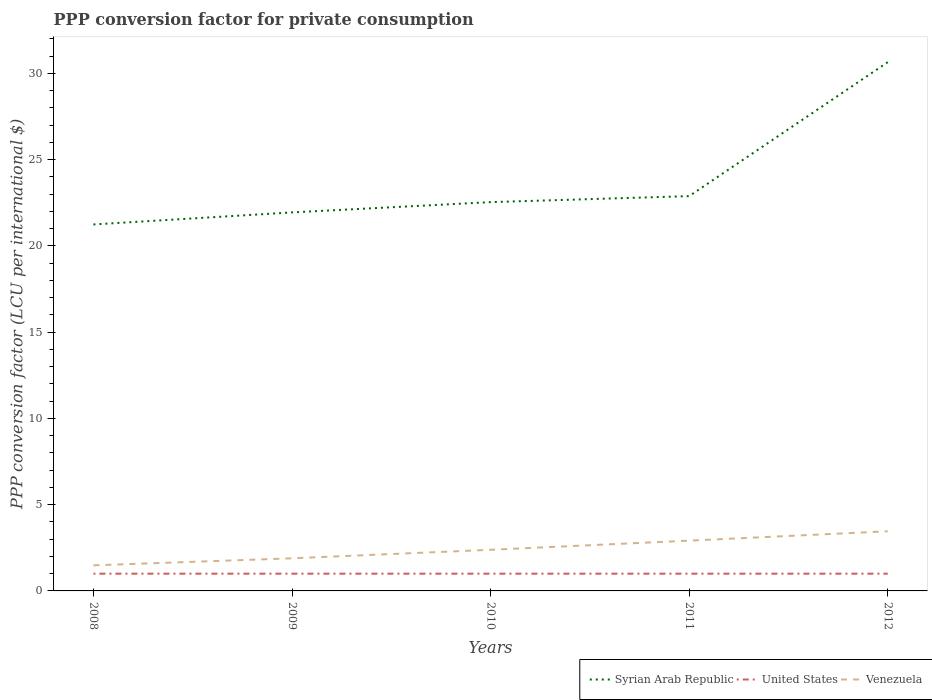Across all years, what is the maximum PPP conversion factor for private consumption in Venezuela?
Your response must be concise. 1.48. What is the total PPP conversion factor for private consumption in Syrian Arab Republic in the graph?
Keep it short and to the point. -7.77. What is the difference between the highest and the second highest PPP conversion factor for private consumption in Syrian Arab Republic?
Make the answer very short. 9.41. Is the PPP conversion factor for private consumption in United States strictly greater than the PPP conversion factor for private consumption in Syrian Arab Republic over the years?
Offer a very short reply. Yes. How many years are there in the graph?
Provide a short and direct response. 5. What is the difference between two consecutive major ticks on the Y-axis?
Provide a short and direct response. 5. Does the graph contain any zero values?
Your answer should be very brief. No. Does the graph contain grids?
Offer a terse response. No. Where does the legend appear in the graph?
Give a very brief answer. Bottom right. How are the legend labels stacked?
Give a very brief answer. Horizontal. What is the title of the graph?
Offer a terse response. PPP conversion factor for private consumption. What is the label or title of the X-axis?
Give a very brief answer. Years. What is the label or title of the Y-axis?
Keep it short and to the point. PPP conversion factor (LCU per international $). What is the PPP conversion factor (LCU per international $) of Syrian Arab Republic in 2008?
Offer a terse response. 21.24. What is the PPP conversion factor (LCU per international $) in Venezuela in 2008?
Ensure brevity in your answer.  1.48. What is the PPP conversion factor (LCU per international $) in Syrian Arab Republic in 2009?
Ensure brevity in your answer.  21.94. What is the PPP conversion factor (LCU per international $) in United States in 2009?
Give a very brief answer. 1. What is the PPP conversion factor (LCU per international $) of Venezuela in 2009?
Make the answer very short. 1.89. What is the PPP conversion factor (LCU per international $) in Syrian Arab Republic in 2010?
Your answer should be very brief. 22.54. What is the PPP conversion factor (LCU per international $) of United States in 2010?
Provide a succinct answer. 1. What is the PPP conversion factor (LCU per international $) of Venezuela in 2010?
Give a very brief answer. 2.38. What is the PPP conversion factor (LCU per international $) of Syrian Arab Republic in 2011?
Provide a succinct answer. 22.89. What is the PPP conversion factor (LCU per international $) in United States in 2011?
Your answer should be compact. 1. What is the PPP conversion factor (LCU per international $) of Venezuela in 2011?
Provide a succinct answer. 2.92. What is the PPP conversion factor (LCU per international $) of Syrian Arab Republic in 2012?
Offer a very short reply. 30.65. What is the PPP conversion factor (LCU per international $) of Venezuela in 2012?
Your answer should be very brief. 3.46. Across all years, what is the maximum PPP conversion factor (LCU per international $) of Syrian Arab Republic?
Your response must be concise. 30.65. Across all years, what is the maximum PPP conversion factor (LCU per international $) in Venezuela?
Provide a short and direct response. 3.46. Across all years, what is the minimum PPP conversion factor (LCU per international $) in Syrian Arab Republic?
Provide a succinct answer. 21.24. Across all years, what is the minimum PPP conversion factor (LCU per international $) of United States?
Offer a terse response. 1. Across all years, what is the minimum PPP conversion factor (LCU per international $) of Venezuela?
Your answer should be compact. 1.48. What is the total PPP conversion factor (LCU per international $) of Syrian Arab Republic in the graph?
Offer a very short reply. 119.26. What is the total PPP conversion factor (LCU per international $) of Venezuela in the graph?
Offer a very short reply. 12.13. What is the difference between the PPP conversion factor (LCU per international $) of Syrian Arab Republic in 2008 and that in 2009?
Your answer should be compact. -0.7. What is the difference between the PPP conversion factor (LCU per international $) in United States in 2008 and that in 2009?
Your answer should be very brief. 0. What is the difference between the PPP conversion factor (LCU per international $) in Venezuela in 2008 and that in 2009?
Provide a succinct answer. -0.41. What is the difference between the PPP conversion factor (LCU per international $) of Syrian Arab Republic in 2008 and that in 2010?
Offer a very short reply. -1.29. What is the difference between the PPP conversion factor (LCU per international $) of Venezuela in 2008 and that in 2010?
Ensure brevity in your answer.  -0.9. What is the difference between the PPP conversion factor (LCU per international $) of Syrian Arab Republic in 2008 and that in 2011?
Your answer should be very brief. -1.64. What is the difference between the PPP conversion factor (LCU per international $) in United States in 2008 and that in 2011?
Your response must be concise. 0. What is the difference between the PPP conversion factor (LCU per international $) in Venezuela in 2008 and that in 2011?
Your answer should be very brief. -1.43. What is the difference between the PPP conversion factor (LCU per international $) in Syrian Arab Republic in 2008 and that in 2012?
Your answer should be very brief. -9.41. What is the difference between the PPP conversion factor (LCU per international $) in Venezuela in 2008 and that in 2012?
Offer a very short reply. -1.97. What is the difference between the PPP conversion factor (LCU per international $) of Syrian Arab Republic in 2009 and that in 2010?
Provide a succinct answer. -0.6. What is the difference between the PPP conversion factor (LCU per international $) of Venezuela in 2009 and that in 2010?
Your answer should be compact. -0.49. What is the difference between the PPP conversion factor (LCU per international $) in Syrian Arab Republic in 2009 and that in 2011?
Your answer should be very brief. -0.94. What is the difference between the PPP conversion factor (LCU per international $) in Venezuela in 2009 and that in 2011?
Your answer should be compact. -1.02. What is the difference between the PPP conversion factor (LCU per international $) in Syrian Arab Republic in 2009 and that in 2012?
Your answer should be very brief. -8.71. What is the difference between the PPP conversion factor (LCU per international $) of United States in 2009 and that in 2012?
Provide a short and direct response. 0. What is the difference between the PPP conversion factor (LCU per international $) of Venezuela in 2009 and that in 2012?
Make the answer very short. -1.57. What is the difference between the PPP conversion factor (LCU per international $) in Syrian Arab Republic in 2010 and that in 2011?
Offer a terse response. -0.35. What is the difference between the PPP conversion factor (LCU per international $) in Venezuela in 2010 and that in 2011?
Give a very brief answer. -0.53. What is the difference between the PPP conversion factor (LCU per international $) of Syrian Arab Republic in 2010 and that in 2012?
Provide a short and direct response. -8.11. What is the difference between the PPP conversion factor (LCU per international $) of Venezuela in 2010 and that in 2012?
Provide a succinct answer. -1.07. What is the difference between the PPP conversion factor (LCU per international $) of Syrian Arab Republic in 2011 and that in 2012?
Your answer should be compact. -7.77. What is the difference between the PPP conversion factor (LCU per international $) of Venezuela in 2011 and that in 2012?
Give a very brief answer. -0.54. What is the difference between the PPP conversion factor (LCU per international $) in Syrian Arab Republic in 2008 and the PPP conversion factor (LCU per international $) in United States in 2009?
Offer a terse response. 20.24. What is the difference between the PPP conversion factor (LCU per international $) of Syrian Arab Republic in 2008 and the PPP conversion factor (LCU per international $) of Venezuela in 2009?
Your answer should be very brief. 19.35. What is the difference between the PPP conversion factor (LCU per international $) of United States in 2008 and the PPP conversion factor (LCU per international $) of Venezuela in 2009?
Provide a succinct answer. -0.89. What is the difference between the PPP conversion factor (LCU per international $) in Syrian Arab Republic in 2008 and the PPP conversion factor (LCU per international $) in United States in 2010?
Your response must be concise. 20.24. What is the difference between the PPP conversion factor (LCU per international $) in Syrian Arab Republic in 2008 and the PPP conversion factor (LCU per international $) in Venezuela in 2010?
Keep it short and to the point. 18.86. What is the difference between the PPP conversion factor (LCU per international $) of United States in 2008 and the PPP conversion factor (LCU per international $) of Venezuela in 2010?
Give a very brief answer. -1.38. What is the difference between the PPP conversion factor (LCU per international $) of Syrian Arab Republic in 2008 and the PPP conversion factor (LCU per international $) of United States in 2011?
Give a very brief answer. 20.24. What is the difference between the PPP conversion factor (LCU per international $) in Syrian Arab Republic in 2008 and the PPP conversion factor (LCU per international $) in Venezuela in 2011?
Offer a terse response. 18.33. What is the difference between the PPP conversion factor (LCU per international $) of United States in 2008 and the PPP conversion factor (LCU per international $) of Venezuela in 2011?
Your response must be concise. -1.92. What is the difference between the PPP conversion factor (LCU per international $) of Syrian Arab Republic in 2008 and the PPP conversion factor (LCU per international $) of United States in 2012?
Ensure brevity in your answer.  20.24. What is the difference between the PPP conversion factor (LCU per international $) in Syrian Arab Republic in 2008 and the PPP conversion factor (LCU per international $) in Venezuela in 2012?
Your answer should be compact. 17.79. What is the difference between the PPP conversion factor (LCU per international $) in United States in 2008 and the PPP conversion factor (LCU per international $) in Venezuela in 2012?
Keep it short and to the point. -2.46. What is the difference between the PPP conversion factor (LCU per international $) in Syrian Arab Republic in 2009 and the PPP conversion factor (LCU per international $) in United States in 2010?
Your answer should be very brief. 20.94. What is the difference between the PPP conversion factor (LCU per international $) in Syrian Arab Republic in 2009 and the PPP conversion factor (LCU per international $) in Venezuela in 2010?
Ensure brevity in your answer.  19.56. What is the difference between the PPP conversion factor (LCU per international $) in United States in 2009 and the PPP conversion factor (LCU per international $) in Venezuela in 2010?
Provide a short and direct response. -1.38. What is the difference between the PPP conversion factor (LCU per international $) of Syrian Arab Republic in 2009 and the PPP conversion factor (LCU per international $) of United States in 2011?
Provide a succinct answer. 20.94. What is the difference between the PPP conversion factor (LCU per international $) of Syrian Arab Republic in 2009 and the PPP conversion factor (LCU per international $) of Venezuela in 2011?
Offer a very short reply. 19.03. What is the difference between the PPP conversion factor (LCU per international $) of United States in 2009 and the PPP conversion factor (LCU per international $) of Venezuela in 2011?
Provide a short and direct response. -1.92. What is the difference between the PPP conversion factor (LCU per international $) in Syrian Arab Republic in 2009 and the PPP conversion factor (LCU per international $) in United States in 2012?
Offer a terse response. 20.94. What is the difference between the PPP conversion factor (LCU per international $) of Syrian Arab Republic in 2009 and the PPP conversion factor (LCU per international $) of Venezuela in 2012?
Offer a terse response. 18.48. What is the difference between the PPP conversion factor (LCU per international $) of United States in 2009 and the PPP conversion factor (LCU per international $) of Venezuela in 2012?
Offer a terse response. -2.46. What is the difference between the PPP conversion factor (LCU per international $) of Syrian Arab Republic in 2010 and the PPP conversion factor (LCU per international $) of United States in 2011?
Your response must be concise. 21.54. What is the difference between the PPP conversion factor (LCU per international $) of Syrian Arab Republic in 2010 and the PPP conversion factor (LCU per international $) of Venezuela in 2011?
Provide a short and direct response. 19.62. What is the difference between the PPP conversion factor (LCU per international $) of United States in 2010 and the PPP conversion factor (LCU per international $) of Venezuela in 2011?
Your answer should be compact. -1.92. What is the difference between the PPP conversion factor (LCU per international $) of Syrian Arab Republic in 2010 and the PPP conversion factor (LCU per international $) of United States in 2012?
Provide a succinct answer. 21.54. What is the difference between the PPP conversion factor (LCU per international $) in Syrian Arab Republic in 2010 and the PPP conversion factor (LCU per international $) in Venezuela in 2012?
Provide a succinct answer. 19.08. What is the difference between the PPP conversion factor (LCU per international $) of United States in 2010 and the PPP conversion factor (LCU per international $) of Venezuela in 2012?
Give a very brief answer. -2.46. What is the difference between the PPP conversion factor (LCU per international $) in Syrian Arab Republic in 2011 and the PPP conversion factor (LCU per international $) in United States in 2012?
Give a very brief answer. 21.89. What is the difference between the PPP conversion factor (LCU per international $) in Syrian Arab Republic in 2011 and the PPP conversion factor (LCU per international $) in Venezuela in 2012?
Provide a succinct answer. 19.43. What is the difference between the PPP conversion factor (LCU per international $) in United States in 2011 and the PPP conversion factor (LCU per international $) in Venezuela in 2012?
Offer a terse response. -2.46. What is the average PPP conversion factor (LCU per international $) in Syrian Arab Republic per year?
Ensure brevity in your answer.  23.85. What is the average PPP conversion factor (LCU per international $) in Venezuela per year?
Provide a short and direct response. 2.43. In the year 2008, what is the difference between the PPP conversion factor (LCU per international $) in Syrian Arab Republic and PPP conversion factor (LCU per international $) in United States?
Offer a terse response. 20.24. In the year 2008, what is the difference between the PPP conversion factor (LCU per international $) of Syrian Arab Republic and PPP conversion factor (LCU per international $) of Venezuela?
Your answer should be very brief. 19.76. In the year 2008, what is the difference between the PPP conversion factor (LCU per international $) in United States and PPP conversion factor (LCU per international $) in Venezuela?
Provide a short and direct response. -0.48. In the year 2009, what is the difference between the PPP conversion factor (LCU per international $) in Syrian Arab Republic and PPP conversion factor (LCU per international $) in United States?
Give a very brief answer. 20.94. In the year 2009, what is the difference between the PPP conversion factor (LCU per international $) in Syrian Arab Republic and PPP conversion factor (LCU per international $) in Venezuela?
Provide a short and direct response. 20.05. In the year 2009, what is the difference between the PPP conversion factor (LCU per international $) of United States and PPP conversion factor (LCU per international $) of Venezuela?
Give a very brief answer. -0.89. In the year 2010, what is the difference between the PPP conversion factor (LCU per international $) in Syrian Arab Republic and PPP conversion factor (LCU per international $) in United States?
Your response must be concise. 21.54. In the year 2010, what is the difference between the PPP conversion factor (LCU per international $) of Syrian Arab Republic and PPP conversion factor (LCU per international $) of Venezuela?
Provide a short and direct response. 20.15. In the year 2010, what is the difference between the PPP conversion factor (LCU per international $) in United States and PPP conversion factor (LCU per international $) in Venezuela?
Offer a terse response. -1.38. In the year 2011, what is the difference between the PPP conversion factor (LCU per international $) of Syrian Arab Republic and PPP conversion factor (LCU per international $) of United States?
Make the answer very short. 21.89. In the year 2011, what is the difference between the PPP conversion factor (LCU per international $) of Syrian Arab Republic and PPP conversion factor (LCU per international $) of Venezuela?
Your answer should be very brief. 19.97. In the year 2011, what is the difference between the PPP conversion factor (LCU per international $) of United States and PPP conversion factor (LCU per international $) of Venezuela?
Your answer should be compact. -1.92. In the year 2012, what is the difference between the PPP conversion factor (LCU per international $) of Syrian Arab Republic and PPP conversion factor (LCU per international $) of United States?
Offer a terse response. 29.65. In the year 2012, what is the difference between the PPP conversion factor (LCU per international $) of Syrian Arab Republic and PPP conversion factor (LCU per international $) of Venezuela?
Your answer should be compact. 27.19. In the year 2012, what is the difference between the PPP conversion factor (LCU per international $) of United States and PPP conversion factor (LCU per international $) of Venezuela?
Your response must be concise. -2.46. What is the ratio of the PPP conversion factor (LCU per international $) of Syrian Arab Republic in 2008 to that in 2009?
Make the answer very short. 0.97. What is the ratio of the PPP conversion factor (LCU per international $) in United States in 2008 to that in 2009?
Ensure brevity in your answer.  1. What is the ratio of the PPP conversion factor (LCU per international $) of Venezuela in 2008 to that in 2009?
Keep it short and to the point. 0.78. What is the ratio of the PPP conversion factor (LCU per international $) in Syrian Arab Republic in 2008 to that in 2010?
Ensure brevity in your answer.  0.94. What is the ratio of the PPP conversion factor (LCU per international $) of United States in 2008 to that in 2010?
Give a very brief answer. 1. What is the ratio of the PPP conversion factor (LCU per international $) in Venezuela in 2008 to that in 2010?
Make the answer very short. 0.62. What is the ratio of the PPP conversion factor (LCU per international $) in Syrian Arab Republic in 2008 to that in 2011?
Keep it short and to the point. 0.93. What is the ratio of the PPP conversion factor (LCU per international $) of Venezuela in 2008 to that in 2011?
Ensure brevity in your answer.  0.51. What is the ratio of the PPP conversion factor (LCU per international $) of Syrian Arab Republic in 2008 to that in 2012?
Offer a terse response. 0.69. What is the ratio of the PPP conversion factor (LCU per international $) in United States in 2008 to that in 2012?
Provide a short and direct response. 1. What is the ratio of the PPP conversion factor (LCU per international $) of Venezuela in 2008 to that in 2012?
Ensure brevity in your answer.  0.43. What is the ratio of the PPP conversion factor (LCU per international $) in Syrian Arab Republic in 2009 to that in 2010?
Provide a succinct answer. 0.97. What is the ratio of the PPP conversion factor (LCU per international $) of Venezuela in 2009 to that in 2010?
Give a very brief answer. 0.79. What is the ratio of the PPP conversion factor (LCU per international $) in Syrian Arab Republic in 2009 to that in 2011?
Give a very brief answer. 0.96. What is the ratio of the PPP conversion factor (LCU per international $) of Venezuela in 2009 to that in 2011?
Provide a short and direct response. 0.65. What is the ratio of the PPP conversion factor (LCU per international $) of Syrian Arab Republic in 2009 to that in 2012?
Your answer should be compact. 0.72. What is the ratio of the PPP conversion factor (LCU per international $) in United States in 2009 to that in 2012?
Ensure brevity in your answer.  1. What is the ratio of the PPP conversion factor (LCU per international $) in Venezuela in 2009 to that in 2012?
Make the answer very short. 0.55. What is the ratio of the PPP conversion factor (LCU per international $) of Venezuela in 2010 to that in 2011?
Provide a succinct answer. 0.82. What is the ratio of the PPP conversion factor (LCU per international $) of Syrian Arab Republic in 2010 to that in 2012?
Your response must be concise. 0.74. What is the ratio of the PPP conversion factor (LCU per international $) in United States in 2010 to that in 2012?
Offer a very short reply. 1. What is the ratio of the PPP conversion factor (LCU per international $) in Venezuela in 2010 to that in 2012?
Ensure brevity in your answer.  0.69. What is the ratio of the PPP conversion factor (LCU per international $) of Syrian Arab Republic in 2011 to that in 2012?
Keep it short and to the point. 0.75. What is the ratio of the PPP conversion factor (LCU per international $) in United States in 2011 to that in 2012?
Ensure brevity in your answer.  1. What is the ratio of the PPP conversion factor (LCU per international $) in Venezuela in 2011 to that in 2012?
Ensure brevity in your answer.  0.84. What is the difference between the highest and the second highest PPP conversion factor (LCU per international $) of Syrian Arab Republic?
Your answer should be compact. 7.77. What is the difference between the highest and the second highest PPP conversion factor (LCU per international $) in Venezuela?
Your answer should be very brief. 0.54. What is the difference between the highest and the lowest PPP conversion factor (LCU per international $) of Syrian Arab Republic?
Keep it short and to the point. 9.41. What is the difference between the highest and the lowest PPP conversion factor (LCU per international $) in United States?
Your response must be concise. 0. What is the difference between the highest and the lowest PPP conversion factor (LCU per international $) of Venezuela?
Offer a terse response. 1.97. 